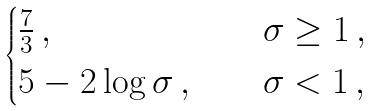Convert formula to latex. <formula><loc_0><loc_0><loc_500><loc_500>\begin{cases} \frac { 7 } { 3 } \, , \quad & \sigma \geq 1 \, , \\ 5 - 2 \log \sigma \, , \quad & \sigma < 1 \, , \end{cases}</formula> 